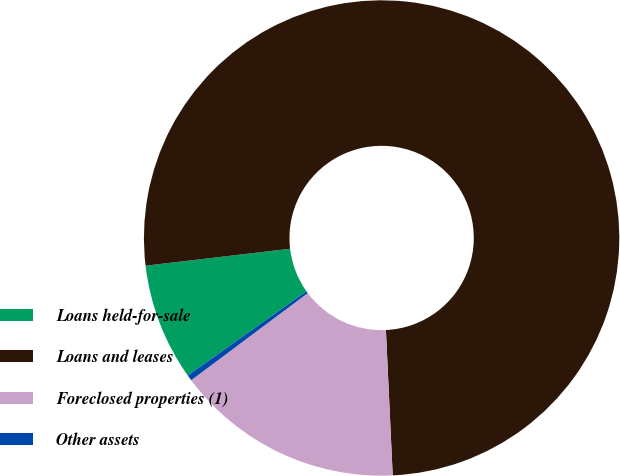Convert chart to OTSL. <chart><loc_0><loc_0><loc_500><loc_500><pie_chart><fcel>Loans held-for-sale<fcel>Loans and leases<fcel>Foreclosed properties (1)<fcel>Other assets<nl><fcel>7.96%<fcel>76.11%<fcel>15.53%<fcel>0.39%<nl></chart> 